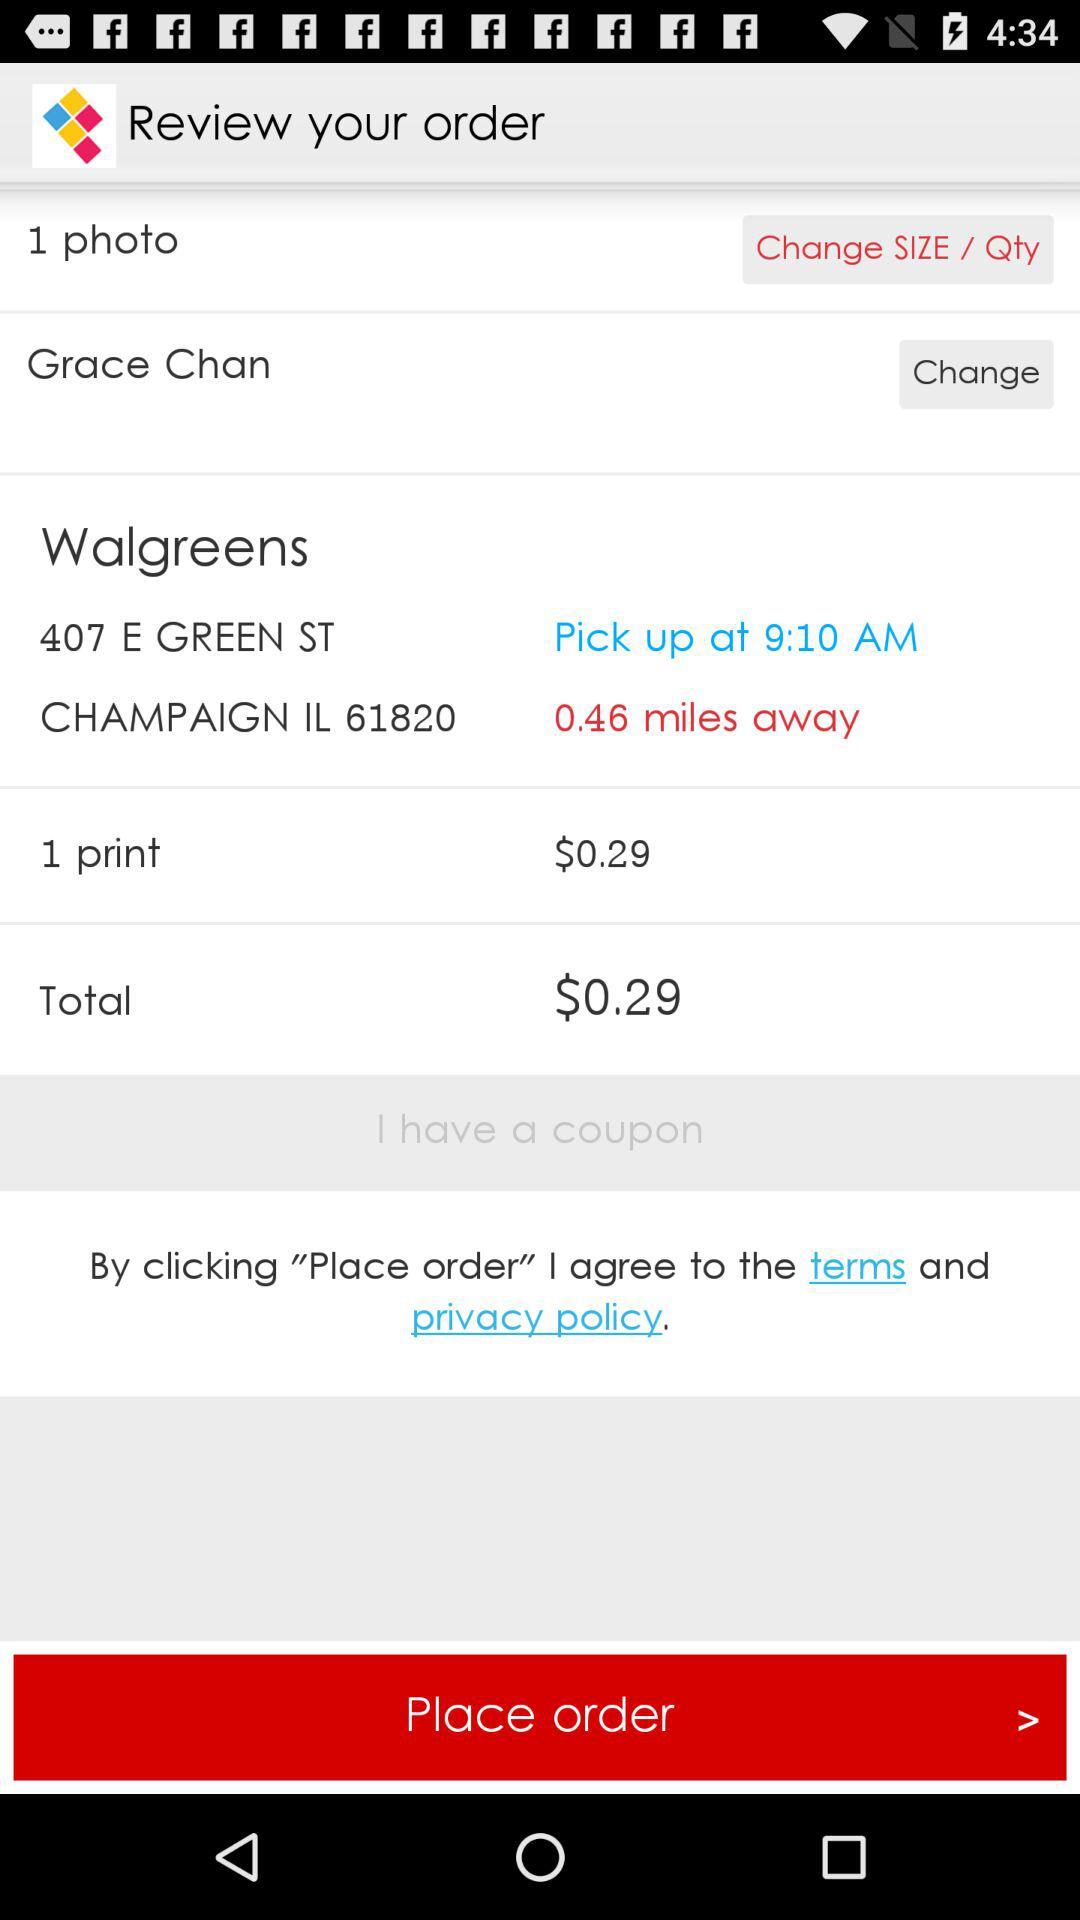How much does one print cost? One print costs $0.29. 